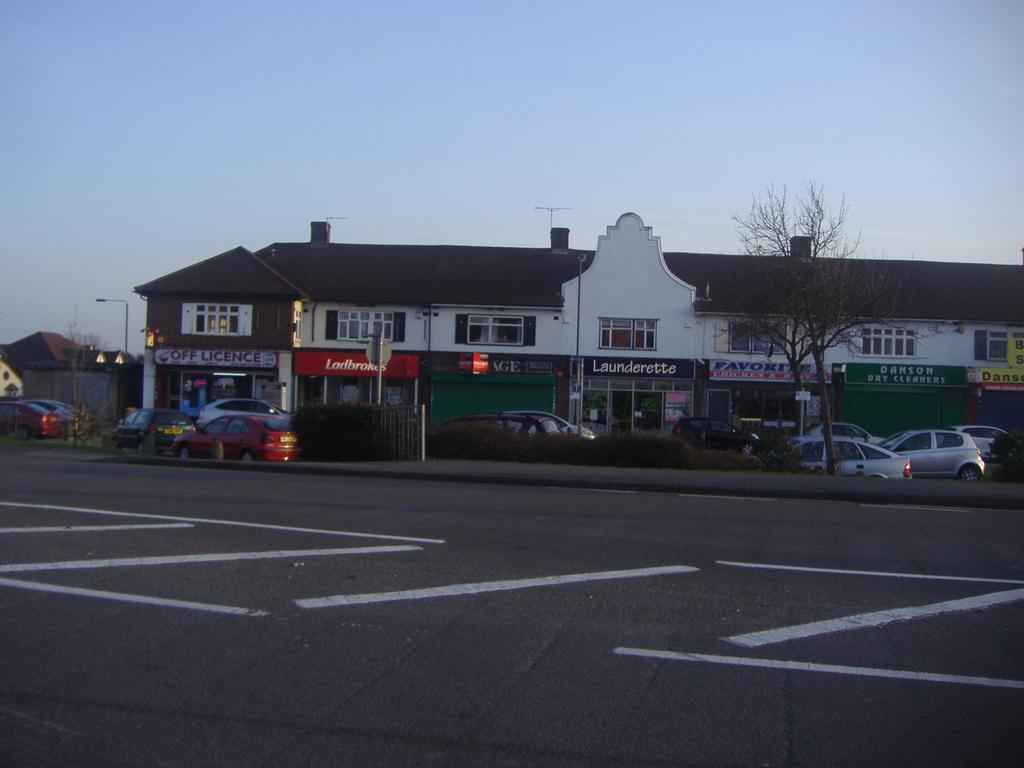Can you describe this image briefly? In this image, we can see a building and some cars beside the road. There is a tree on the right side of the image. In the background of the image, there is a sky. 